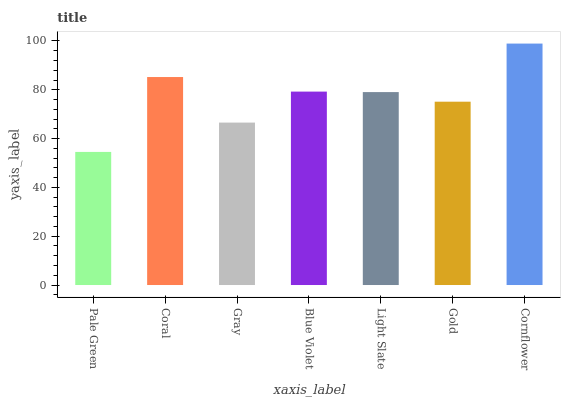Is Pale Green the minimum?
Answer yes or no. Yes. Is Cornflower the maximum?
Answer yes or no. Yes. Is Coral the minimum?
Answer yes or no. No. Is Coral the maximum?
Answer yes or no. No. Is Coral greater than Pale Green?
Answer yes or no. Yes. Is Pale Green less than Coral?
Answer yes or no. Yes. Is Pale Green greater than Coral?
Answer yes or no. No. Is Coral less than Pale Green?
Answer yes or no. No. Is Light Slate the high median?
Answer yes or no. Yes. Is Light Slate the low median?
Answer yes or no. Yes. Is Coral the high median?
Answer yes or no. No. Is Cornflower the low median?
Answer yes or no. No. 